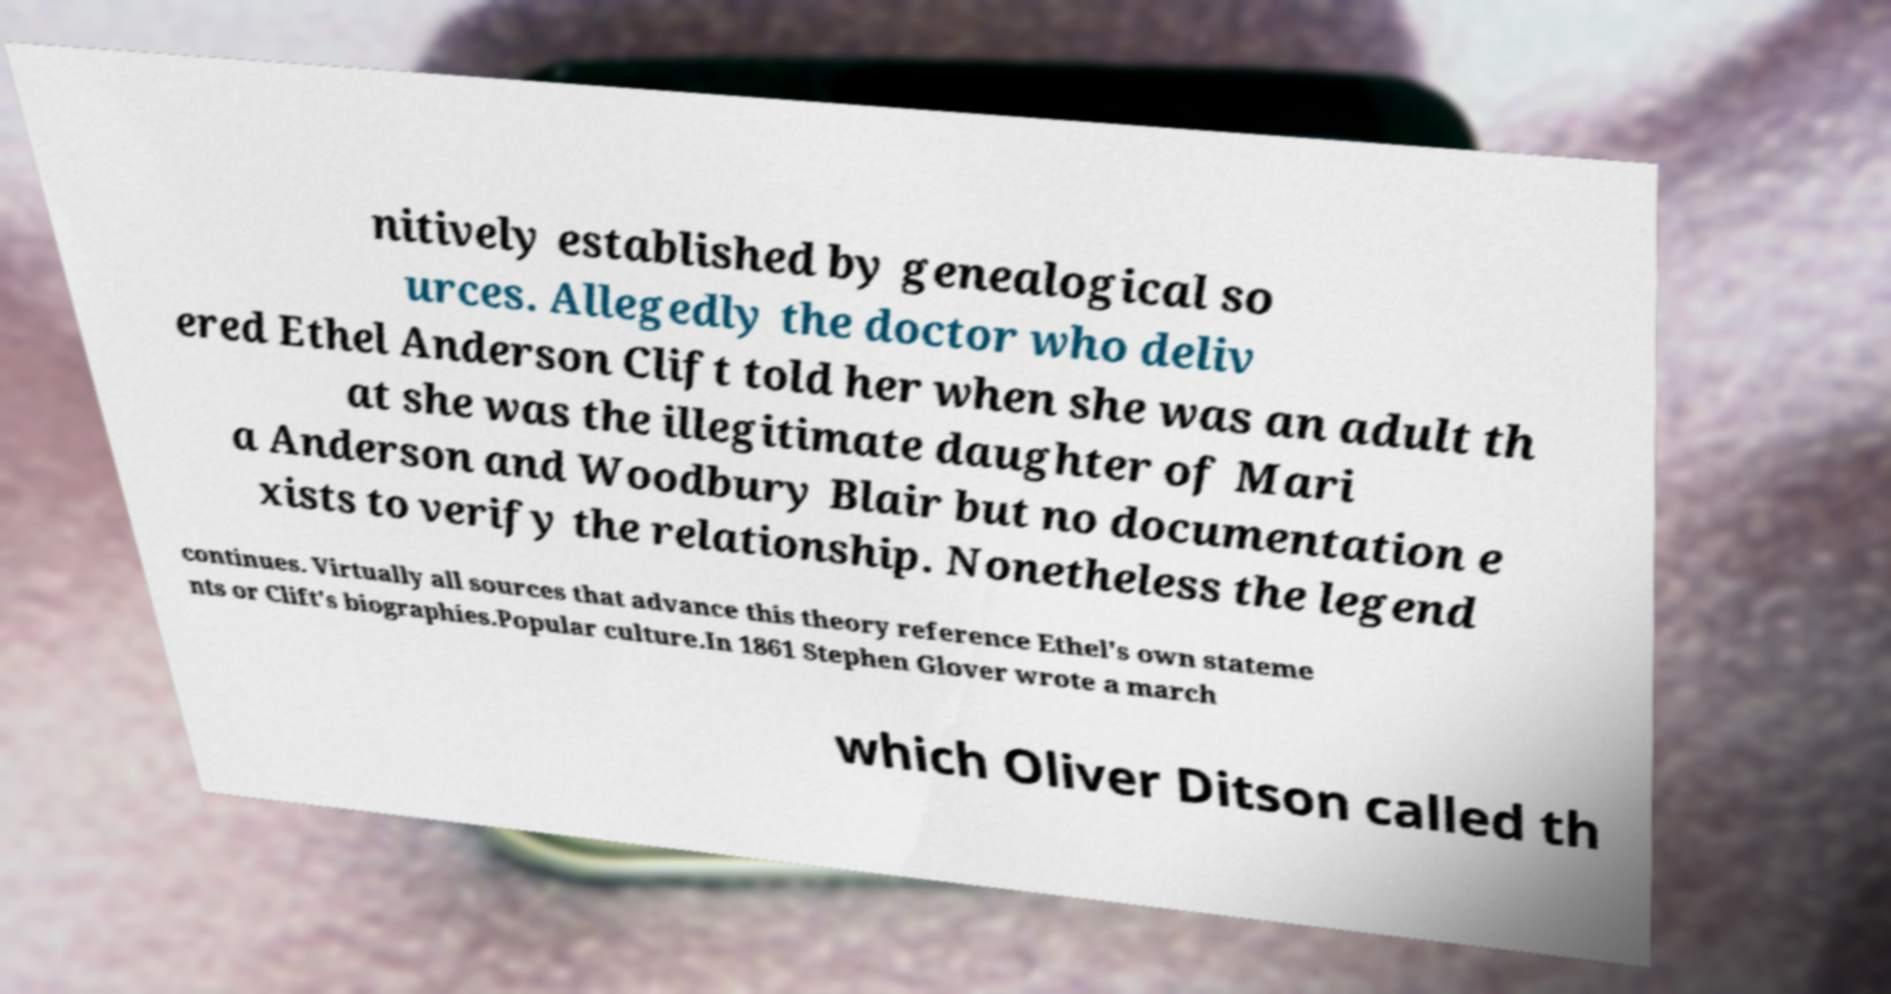Please identify and transcribe the text found in this image. nitively established by genealogical so urces. Allegedly the doctor who deliv ered Ethel Anderson Clift told her when she was an adult th at she was the illegitimate daughter of Mari a Anderson and Woodbury Blair but no documentation e xists to verify the relationship. Nonetheless the legend continues. Virtually all sources that advance this theory reference Ethel's own stateme nts or Clift's biographies.Popular culture.In 1861 Stephen Glover wrote a march which Oliver Ditson called th 